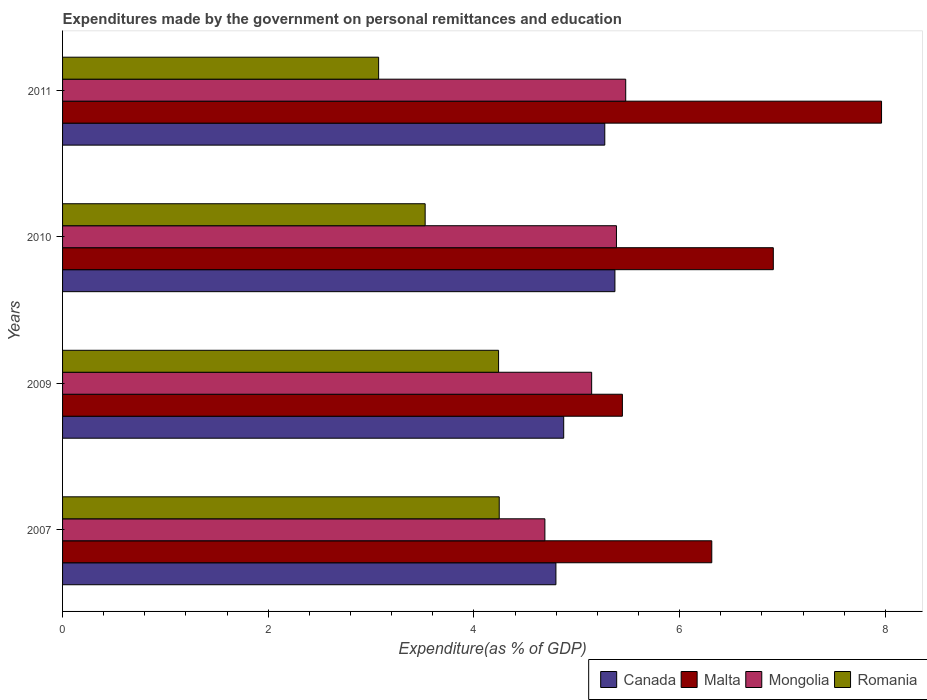Are the number of bars per tick equal to the number of legend labels?
Your answer should be very brief. Yes. How many bars are there on the 3rd tick from the top?
Ensure brevity in your answer.  4. In how many cases, is the number of bars for a given year not equal to the number of legend labels?
Ensure brevity in your answer.  0. What is the expenditures made by the government on personal remittances and education in Canada in 2011?
Your answer should be compact. 5.27. Across all years, what is the maximum expenditures made by the government on personal remittances and education in Romania?
Provide a succinct answer. 4.25. Across all years, what is the minimum expenditures made by the government on personal remittances and education in Romania?
Make the answer very short. 3.07. In which year was the expenditures made by the government on personal remittances and education in Canada maximum?
Your response must be concise. 2010. In which year was the expenditures made by the government on personal remittances and education in Mongolia minimum?
Keep it short and to the point. 2007. What is the total expenditures made by the government on personal remittances and education in Canada in the graph?
Your response must be concise. 20.31. What is the difference between the expenditures made by the government on personal remittances and education in Malta in 2007 and that in 2010?
Your answer should be very brief. -0.6. What is the difference between the expenditures made by the government on personal remittances and education in Mongolia in 2010 and the expenditures made by the government on personal remittances and education in Malta in 2009?
Offer a very short reply. -0.06. What is the average expenditures made by the government on personal remittances and education in Canada per year?
Provide a succinct answer. 5.08. In the year 2007, what is the difference between the expenditures made by the government on personal remittances and education in Romania and expenditures made by the government on personal remittances and education in Malta?
Your answer should be very brief. -2.07. In how many years, is the expenditures made by the government on personal remittances and education in Romania greater than 0.8 %?
Your answer should be very brief. 4. What is the ratio of the expenditures made by the government on personal remittances and education in Malta in 2010 to that in 2011?
Your answer should be compact. 0.87. Is the expenditures made by the government on personal remittances and education in Mongolia in 2007 less than that in 2010?
Your answer should be compact. Yes. Is the difference between the expenditures made by the government on personal remittances and education in Romania in 2010 and 2011 greater than the difference between the expenditures made by the government on personal remittances and education in Malta in 2010 and 2011?
Keep it short and to the point. Yes. What is the difference between the highest and the second highest expenditures made by the government on personal remittances and education in Canada?
Provide a succinct answer. 0.1. What is the difference between the highest and the lowest expenditures made by the government on personal remittances and education in Mongolia?
Make the answer very short. 0.79. In how many years, is the expenditures made by the government on personal remittances and education in Canada greater than the average expenditures made by the government on personal remittances and education in Canada taken over all years?
Provide a succinct answer. 2. Is the sum of the expenditures made by the government on personal remittances and education in Mongolia in 2007 and 2009 greater than the maximum expenditures made by the government on personal remittances and education in Canada across all years?
Keep it short and to the point. Yes. Is it the case that in every year, the sum of the expenditures made by the government on personal remittances and education in Romania and expenditures made by the government on personal remittances and education in Mongolia is greater than the sum of expenditures made by the government on personal remittances and education in Malta and expenditures made by the government on personal remittances and education in Canada?
Provide a short and direct response. No. What does the 1st bar from the top in 2009 represents?
Offer a very short reply. Romania. What does the 3rd bar from the bottom in 2009 represents?
Make the answer very short. Mongolia. How many years are there in the graph?
Give a very brief answer. 4. What is the difference between two consecutive major ticks on the X-axis?
Give a very brief answer. 2. Does the graph contain grids?
Your response must be concise. No. Where does the legend appear in the graph?
Your response must be concise. Bottom right. How are the legend labels stacked?
Offer a terse response. Horizontal. What is the title of the graph?
Your response must be concise. Expenditures made by the government on personal remittances and education. What is the label or title of the X-axis?
Your answer should be compact. Expenditure(as % of GDP). What is the label or title of the Y-axis?
Offer a terse response. Years. What is the Expenditure(as % of GDP) of Canada in 2007?
Keep it short and to the point. 4.8. What is the Expenditure(as % of GDP) in Malta in 2007?
Make the answer very short. 6.31. What is the Expenditure(as % of GDP) of Mongolia in 2007?
Provide a succinct answer. 4.69. What is the Expenditure(as % of GDP) of Romania in 2007?
Your response must be concise. 4.25. What is the Expenditure(as % of GDP) in Canada in 2009?
Offer a terse response. 4.87. What is the Expenditure(as % of GDP) in Malta in 2009?
Provide a succinct answer. 5.44. What is the Expenditure(as % of GDP) of Mongolia in 2009?
Keep it short and to the point. 5.14. What is the Expenditure(as % of GDP) of Romania in 2009?
Keep it short and to the point. 4.24. What is the Expenditure(as % of GDP) of Canada in 2010?
Your answer should be very brief. 5.37. What is the Expenditure(as % of GDP) in Malta in 2010?
Your answer should be very brief. 6.91. What is the Expenditure(as % of GDP) in Mongolia in 2010?
Provide a succinct answer. 5.39. What is the Expenditure(as % of GDP) of Romania in 2010?
Give a very brief answer. 3.53. What is the Expenditure(as % of GDP) of Canada in 2011?
Offer a very short reply. 5.27. What is the Expenditure(as % of GDP) of Malta in 2011?
Ensure brevity in your answer.  7.96. What is the Expenditure(as % of GDP) in Mongolia in 2011?
Your answer should be very brief. 5.48. What is the Expenditure(as % of GDP) of Romania in 2011?
Provide a short and direct response. 3.07. Across all years, what is the maximum Expenditure(as % of GDP) in Canada?
Your answer should be very brief. 5.37. Across all years, what is the maximum Expenditure(as % of GDP) of Malta?
Keep it short and to the point. 7.96. Across all years, what is the maximum Expenditure(as % of GDP) of Mongolia?
Your response must be concise. 5.48. Across all years, what is the maximum Expenditure(as % of GDP) in Romania?
Offer a very short reply. 4.25. Across all years, what is the minimum Expenditure(as % of GDP) of Canada?
Ensure brevity in your answer.  4.8. Across all years, what is the minimum Expenditure(as % of GDP) in Malta?
Offer a terse response. 5.44. Across all years, what is the minimum Expenditure(as % of GDP) in Mongolia?
Provide a succinct answer. 4.69. Across all years, what is the minimum Expenditure(as % of GDP) in Romania?
Your answer should be very brief. 3.07. What is the total Expenditure(as % of GDP) of Canada in the graph?
Your answer should be very brief. 20.31. What is the total Expenditure(as % of GDP) in Malta in the graph?
Ensure brevity in your answer.  26.63. What is the total Expenditure(as % of GDP) in Mongolia in the graph?
Provide a short and direct response. 20.7. What is the total Expenditure(as % of GDP) in Romania in the graph?
Your answer should be very brief. 15.09. What is the difference between the Expenditure(as % of GDP) of Canada in 2007 and that in 2009?
Your response must be concise. -0.08. What is the difference between the Expenditure(as % of GDP) of Malta in 2007 and that in 2009?
Make the answer very short. 0.87. What is the difference between the Expenditure(as % of GDP) of Mongolia in 2007 and that in 2009?
Offer a terse response. -0.45. What is the difference between the Expenditure(as % of GDP) in Romania in 2007 and that in 2009?
Your response must be concise. 0.01. What is the difference between the Expenditure(as % of GDP) in Canada in 2007 and that in 2010?
Make the answer very short. -0.57. What is the difference between the Expenditure(as % of GDP) in Malta in 2007 and that in 2010?
Give a very brief answer. -0.6. What is the difference between the Expenditure(as % of GDP) in Mongolia in 2007 and that in 2010?
Provide a short and direct response. -0.7. What is the difference between the Expenditure(as % of GDP) in Romania in 2007 and that in 2010?
Provide a short and direct response. 0.72. What is the difference between the Expenditure(as % of GDP) of Canada in 2007 and that in 2011?
Offer a very short reply. -0.48. What is the difference between the Expenditure(as % of GDP) of Malta in 2007 and that in 2011?
Your response must be concise. -1.65. What is the difference between the Expenditure(as % of GDP) in Mongolia in 2007 and that in 2011?
Make the answer very short. -0.79. What is the difference between the Expenditure(as % of GDP) in Romania in 2007 and that in 2011?
Keep it short and to the point. 1.17. What is the difference between the Expenditure(as % of GDP) in Canada in 2009 and that in 2010?
Offer a terse response. -0.5. What is the difference between the Expenditure(as % of GDP) of Malta in 2009 and that in 2010?
Your answer should be compact. -1.47. What is the difference between the Expenditure(as % of GDP) in Mongolia in 2009 and that in 2010?
Your answer should be very brief. -0.24. What is the difference between the Expenditure(as % of GDP) in Romania in 2009 and that in 2010?
Your answer should be very brief. 0.71. What is the difference between the Expenditure(as % of GDP) of Canada in 2009 and that in 2011?
Your answer should be compact. -0.4. What is the difference between the Expenditure(as % of GDP) in Malta in 2009 and that in 2011?
Offer a terse response. -2.52. What is the difference between the Expenditure(as % of GDP) in Mongolia in 2009 and that in 2011?
Provide a succinct answer. -0.33. What is the difference between the Expenditure(as % of GDP) of Romania in 2009 and that in 2011?
Ensure brevity in your answer.  1.17. What is the difference between the Expenditure(as % of GDP) in Canada in 2010 and that in 2011?
Keep it short and to the point. 0.1. What is the difference between the Expenditure(as % of GDP) of Malta in 2010 and that in 2011?
Offer a very short reply. -1.05. What is the difference between the Expenditure(as % of GDP) in Mongolia in 2010 and that in 2011?
Your response must be concise. -0.09. What is the difference between the Expenditure(as % of GDP) of Romania in 2010 and that in 2011?
Make the answer very short. 0.45. What is the difference between the Expenditure(as % of GDP) in Canada in 2007 and the Expenditure(as % of GDP) in Malta in 2009?
Your answer should be compact. -0.65. What is the difference between the Expenditure(as % of GDP) in Canada in 2007 and the Expenditure(as % of GDP) in Mongolia in 2009?
Ensure brevity in your answer.  -0.35. What is the difference between the Expenditure(as % of GDP) in Canada in 2007 and the Expenditure(as % of GDP) in Romania in 2009?
Your answer should be very brief. 0.56. What is the difference between the Expenditure(as % of GDP) in Malta in 2007 and the Expenditure(as % of GDP) in Mongolia in 2009?
Your answer should be compact. 1.17. What is the difference between the Expenditure(as % of GDP) in Malta in 2007 and the Expenditure(as % of GDP) in Romania in 2009?
Offer a very short reply. 2.07. What is the difference between the Expenditure(as % of GDP) of Mongolia in 2007 and the Expenditure(as % of GDP) of Romania in 2009?
Provide a short and direct response. 0.45. What is the difference between the Expenditure(as % of GDP) in Canada in 2007 and the Expenditure(as % of GDP) in Malta in 2010?
Make the answer very short. -2.11. What is the difference between the Expenditure(as % of GDP) of Canada in 2007 and the Expenditure(as % of GDP) of Mongolia in 2010?
Ensure brevity in your answer.  -0.59. What is the difference between the Expenditure(as % of GDP) in Canada in 2007 and the Expenditure(as % of GDP) in Romania in 2010?
Your answer should be compact. 1.27. What is the difference between the Expenditure(as % of GDP) of Malta in 2007 and the Expenditure(as % of GDP) of Mongolia in 2010?
Provide a short and direct response. 0.93. What is the difference between the Expenditure(as % of GDP) of Malta in 2007 and the Expenditure(as % of GDP) of Romania in 2010?
Give a very brief answer. 2.79. What is the difference between the Expenditure(as % of GDP) of Mongolia in 2007 and the Expenditure(as % of GDP) of Romania in 2010?
Your response must be concise. 1.16. What is the difference between the Expenditure(as % of GDP) of Canada in 2007 and the Expenditure(as % of GDP) of Malta in 2011?
Make the answer very short. -3.17. What is the difference between the Expenditure(as % of GDP) in Canada in 2007 and the Expenditure(as % of GDP) in Mongolia in 2011?
Make the answer very short. -0.68. What is the difference between the Expenditure(as % of GDP) of Canada in 2007 and the Expenditure(as % of GDP) of Romania in 2011?
Ensure brevity in your answer.  1.72. What is the difference between the Expenditure(as % of GDP) in Malta in 2007 and the Expenditure(as % of GDP) in Mongolia in 2011?
Your answer should be very brief. 0.84. What is the difference between the Expenditure(as % of GDP) in Malta in 2007 and the Expenditure(as % of GDP) in Romania in 2011?
Your answer should be compact. 3.24. What is the difference between the Expenditure(as % of GDP) in Mongolia in 2007 and the Expenditure(as % of GDP) in Romania in 2011?
Offer a very short reply. 1.62. What is the difference between the Expenditure(as % of GDP) in Canada in 2009 and the Expenditure(as % of GDP) in Malta in 2010?
Your response must be concise. -2.04. What is the difference between the Expenditure(as % of GDP) in Canada in 2009 and the Expenditure(as % of GDP) in Mongolia in 2010?
Give a very brief answer. -0.51. What is the difference between the Expenditure(as % of GDP) in Canada in 2009 and the Expenditure(as % of GDP) in Romania in 2010?
Your answer should be very brief. 1.35. What is the difference between the Expenditure(as % of GDP) of Malta in 2009 and the Expenditure(as % of GDP) of Mongolia in 2010?
Provide a succinct answer. 0.06. What is the difference between the Expenditure(as % of GDP) in Malta in 2009 and the Expenditure(as % of GDP) in Romania in 2010?
Provide a short and direct response. 1.92. What is the difference between the Expenditure(as % of GDP) in Mongolia in 2009 and the Expenditure(as % of GDP) in Romania in 2010?
Give a very brief answer. 1.62. What is the difference between the Expenditure(as % of GDP) in Canada in 2009 and the Expenditure(as % of GDP) in Malta in 2011?
Provide a succinct answer. -3.09. What is the difference between the Expenditure(as % of GDP) in Canada in 2009 and the Expenditure(as % of GDP) in Mongolia in 2011?
Ensure brevity in your answer.  -0.6. What is the difference between the Expenditure(as % of GDP) in Canada in 2009 and the Expenditure(as % of GDP) in Romania in 2011?
Provide a succinct answer. 1.8. What is the difference between the Expenditure(as % of GDP) of Malta in 2009 and the Expenditure(as % of GDP) of Mongolia in 2011?
Provide a short and direct response. -0.03. What is the difference between the Expenditure(as % of GDP) of Malta in 2009 and the Expenditure(as % of GDP) of Romania in 2011?
Your answer should be very brief. 2.37. What is the difference between the Expenditure(as % of GDP) in Mongolia in 2009 and the Expenditure(as % of GDP) in Romania in 2011?
Your response must be concise. 2.07. What is the difference between the Expenditure(as % of GDP) of Canada in 2010 and the Expenditure(as % of GDP) of Malta in 2011?
Your response must be concise. -2.59. What is the difference between the Expenditure(as % of GDP) of Canada in 2010 and the Expenditure(as % of GDP) of Mongolia in 2011?
Provide a succinct answer. -0.1. What is the difference between the Expenditure(as % of GDP) of Canada in 2010 and the Expenditure(as % of GDP) of Romania in 2011?
Provide a succinct answer. 2.3. What is the difference between the Expenditure(as % of GDP) in Malta in 2010 and the Expenditure(as % of GDP) in Mongolia in 2011?
Your answer should be very brief. 1.44. What is the difference between the Expenditure(as % of GDP) in Malta in 2010 and the Expenditure(as % of GDP) in Romania in 2011?
Provide a succinct answer. 3.84. What is the difference between the Expenditure(as % of GDP) of Mongolia in 2010 and the Expenditure(as % of GDP) of Romania in 2011?
Offer a very short reply. 2.31. What is the average Expenditure(as % of GDP) of Canada per year?
Keep it short and to the point. 5.08. What is the average Expenditure(as % of GDP) of Malta per year?
Offer a terse response. 6.66. What is the average Expenditure(as % of GDP) of Mongolia per year?
Your answer should be very brief. 5.17. What is the average Expenditure(as % of GDP) in Romania per year?
Offer a terse response. 3.77. In the year 2007, what is the difference between the Expenditure(as % of GDP) in Canada and Expenditure(as % of GDP) in Malta?
Ensure brevity in your answer.  -1.52. In the year 2007, what is the difference between the Expenditure(as % of GDP) in Canada and Expenditure(as % of GDP) in Mongolia?
Your answer should be compact. 0.11. In the year 2007, what is the difference between the Expenditure(as % of GDP) of Canada and Expenditure(as % of GDP) of Romania?
Make the answer very short. 0.55. In the year 2007, what is the difference between the Expenditure(as % of GDP) in Malta and Expenditure(as % of GDP) in Mongolia?
Your answer should be very brief. 1.62. In the year 2007, what is the difference between the Expenditure(as % of GDP) in Malta and Expenditure(as % of GDP) in Romania?
Your answer should be compact. 2.07. In the year 2007, what is the difference between the Expenditure(as % of GDP) of Mongolia and Expenditure(as % of GDP) of Romania?
Provide a succinct answer. 0.44. In the year 2009, what is the difference between the Expenditure(as % of GDP) in Canada and Expenditure(as % of GDP) in Malta?
Make the answer very short. -0.57. In the year 2009, what is the difference between the Expenditure(as % of GDP) of Canada and Expenditure(as % of GDP) of Mongolia?
Provide a short and direct response. -0.27. In the year 2009, what is the difference between the Expenditure(as % of GDP) of Canada and Expenditure(as % of GDP) of Romania?
Make the answer very short. 0.63. In the year 2009, what is the difference between the Expenditure(as % of GDP) of Malta and Expenditure(as % of GDP) of Mongolia?
Keep it short and to the point. 0.3. In the year 2009, what is the difference between the Expenditure(as % of GDP) of Malta and Expenditure(as % of GDP) of Romania?
Make the answer very short. 1.2. In the year 2009, what is the difference between the Expenditure(as % of GDP) of Mongolia and Expenditure(as % of GDP) of Romania?
Provide a succinct answer. 0.91. In the year 2010, what is the difference between the Expenditure(as % of GDP) of Canada and Expenditure(as % of GDP) of Malta?
Offer a very short reply. -1.54. In the year 2010, what is the difference between the Expenditure(as % of GDP) in Canada and Expenditure(as % of GDP) in Mongolia?
Give a very brief answer. -0.01. In the year 2010, what is the difference between the Expenditure(as % of GDP) in Canada and Expenditure(as % of GDP) in Romania?
Provide a short and direct response. 1.85. In the year 2010, what is the difference between the Expenditure(as % of GDP) in Malta and Expenditure(as % of GDP) in Mongolia?
Your answer should be compact. 1.53. In the year 2010, what is the difference between the Expenditure(as % of GDP) of Malta and Expenditure(as % of GDP) of Romania?
Provide a short and direct response. 3.39. In the year 2010, what is the difference between the Expenditure(as % of GDP) in Mongolia and Expenditure(as % of GDP) in Romania?
Your response must be concise. 1.86. In the year 2011, what is the difference between the Expenditure(as % of GDP) in Canada and Expenditure(as % of GDP) in Malta?
Make the answer very short. -2.69. In the year 2011, what is the difference between the Expenditure(as % of GDP) in Canada and Expenditure(as % of GDP) in Mongolia?
Give a very brief answer. -0.2. In the year 2011, what is the difference between the Expenditure(as % of GDP) in Canada and Expenditure(as % of GDP) in Romania?
Your answer should be very brief. 2.2. In the year 2011, what is the difference between the Expenditure(as % of GDP) of Malta and Expenditure(as % of GDP) of Mongolia?
Your answer should be very brief. 2.49. In the year 2011, what is the difference between the Expenditure(as % of GDP) in Malta and Expenditure(as % of GDP) in Romania?
Make the answer very short. 4.89. In the year 2011, what is the difference between the Expenditure(as % of GDP) in Mongolia and Expenditure(as % of GDP) in Romania?
Your answer should be very brief. 2.4. What is the ratio of the Expenditure(as % of GDP) in Canada in 2007 to that in 2009?
Your answer should be very brief. 0.98. What is the ratio of the Expenditure(as % of GDP) in Malta in 2007 to that in 2009?
Give a very brief answer. 1.16. What is the ratio of the Expenditure(as % of GDP) in Mongolia in 2007 to that in 2009?
Provide a short and direct response. 0.91. What is the ratio of the Expenditure(as % of GDP) of Canada in 2007 to that in 2010?
Your response must be concise. 0.89. What is the ratio of the Expenditure(as % of GDP) in Malta in 2007 to that in 2010?
Keep it short and to the point. 0.91. What is the ratio of the Expenditure(as % of GDP) in Mongolia in 2007 to that in 2010?
Make the answer very short. 0.87. What is the ratio of the Expenditure(as % of GDP) in Romania in 2007 to that in 2010?
Your answer should be compact. 1.2. What is the ratio of the Expenditure(as % of GDP) of Canada in 2007 to that in 2011?
Ensure brevity in your answer.  0.91. What is the ratio of the Expenditure(as % of GDP) in Malta in 2007 to that in 2011?
Provide a succinct answer. 0.79. What is the ratio of the Expenditure(as % of GDP) of Mongolia in 2007 to that in 2011?
Keep it short and to the point. 0.86. What is the ratio of the Expenditure(as % of GDP) of Romania in 2007 to that in 2011?
Your answer should be compact. 1.38. What is the ratio of the Expenditure(as % of GDP) of Canada in 2009 to that in 2010?
Provide a succinct answer. 0.91. What is the ratio of the Expenditure(as % of GDP) in Malta in 2009 to that in 2010?
Offer a very short reply. 0.79. What is the ratio of the Expenditure(as % of GDP) of Mongolia in 2009 to that in 2010?
Offer a very short reply. 0.96. What is the ratio of the Expenditure(as % of GDP) in Romania in 2009 to that in 2010?
Your answer should be compact. 1.2. What is the ratio of the Expenditure(as % of GDP) in Canada in 2009 to that in 2011?
Your answer should be compact. 0.92. What is the ratio of the Expenditure(as % of GDP) in Malta in 2009 to that in 2011?
Offer a terse response. 0.68. What is the ratio of the Expenditure(as % of GDP) of Mongolia in 2009 to that in 2011?
Provide a short and direct response. 0.94. What is the ratio of the Expenditure(as % of GDP) of Romania in 2009 to that in 2011?
Your answer should be compact. 1.38. What is the ratio of the Expenditure(as % of GDP) of Canada in 2010 to that in 2011?
Give a very brief answer. 1.02. What is the ratio of the Expenditure(as % of GDP) of Malta in 2010 to that in 2011?
Provide a short and direct response. 0.87. What is the ratio of the Expenditure(as % of GDP) of Mongolia in 2010 to that in 2011?
Make the answer very short. 0.98. What is the ratio of the Expenditure(as % of GDP) in Romania in 2010 to that in 2011?
Keep it short and to the point. 1.15. What is the difference between the highest and the second highest Expenditure(as % of GDP) of Canada?
Your answer should be compact. 0.1. What is the difference between the highest and the second highest Expenditure(as % of GDP) of Malta?
Offer a terse response. 1.05. What is the difference between the highest and the second highest Expenditure(as % of GDP) of Mongolia?
Keep it short and to the point. 0.09. What is the difference between the highest and the second highest Expenditure(as % of GDP) of Romania?
Give a very brief answer. 0.01. What is the difference between the highest and the lowest Expenditure(as % of GDP) in Canada?
Offer a terse response. 0.57. What is the difference between the highest and the lowest Expenditure(as % of GDP) of Malta?
Give a very brief answer. 2.52. What is the difference between the highest and the lowest Expenditure(as % of GDP) of Mongolia?
Your answer should be very brief. 0.79. What is the difference between the highest and the lowest Expenditure(as % of GDP) in Romania?
Provide a succinct answer. 1.17. 